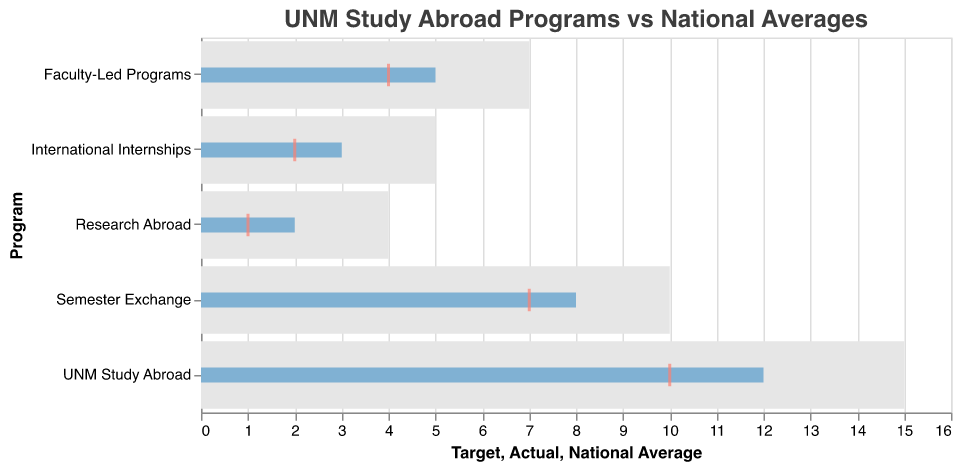What's the title of the chart? The title of the chart is displayed at the top and is generally larger in font size compared to other text elements in the chart. It sums up the focus of the chart, which is "UNM Study Abroad Programs vs National Averages".
Answer: "UNM Study Abroad Programs vs National Averages" How many different study abroad program types are displayed in the chart? By examining the y-axis, which lists the different program types, you can count the number of unique program types presented.
Answer: 5 Which program type had the highest actual participation percentage? By looking at the length of the blue bars, which represent actual percentages, you can identify the longest bar. "UNM Study Abroad" has the longest blue bar, indicating the highest actual participation percentage.
Answer: UNM Study Abroad What is the difference between the target percentage and the actual percentage for "International Internships"? The target percentage for "International Internships" is the end of the light gray bar (5), and the actual percentage is the length of the blue bar (3). The difference can be calculated by subtracting the actual percentage from the target percentage: 5 - 3 = 2.
Answer: 2 Which program type exceeded the national average by the largest percentage? To determine this, compare the position of the orange ticks (national averages) and the blue bars (actual percentages). Calculate the difference for each program and find the maximum. For "UNM Study Abroad", the difference is 12 - 10 = 2. For "Semester Exchange", it's 8 - 7 = 1. For "Faculty-Led Programs", it's 5 - 4 = 1. For "International Internships", it's 3 - 2 = 1. For "Research Abroad", it's 2 - 1 = 1. "UNM Study Abroad" exceeds the national average by the largest margin of 2.
Answer: UNM Study Abroad Are there any programs where the actual percentage is equal to the national average? By comparing the blue bars (actual percentages) with the orange ticks (national averages), note if they align for any program type. No blue bar aligns entirely with any orange tick.
Answer: No Which program type had the smallest actual participation percentage, and what was that percentage? By looking at the length of the blue bars, identify the shortest one, which represents the smallest actual percentage. "Research Abroad" has the shortest blue bar, indicating an actual participation percentage of 2.
Answer: Research Abroad, 2% How many program types had their actual participation percentage below their target? By comparing the blue bars (actual percentages) with the ends of the light gray bars (targets), count how many of the blue bars fall short of their respective targets. All five program types have their actual percentages below their targets.
Answer: 5 